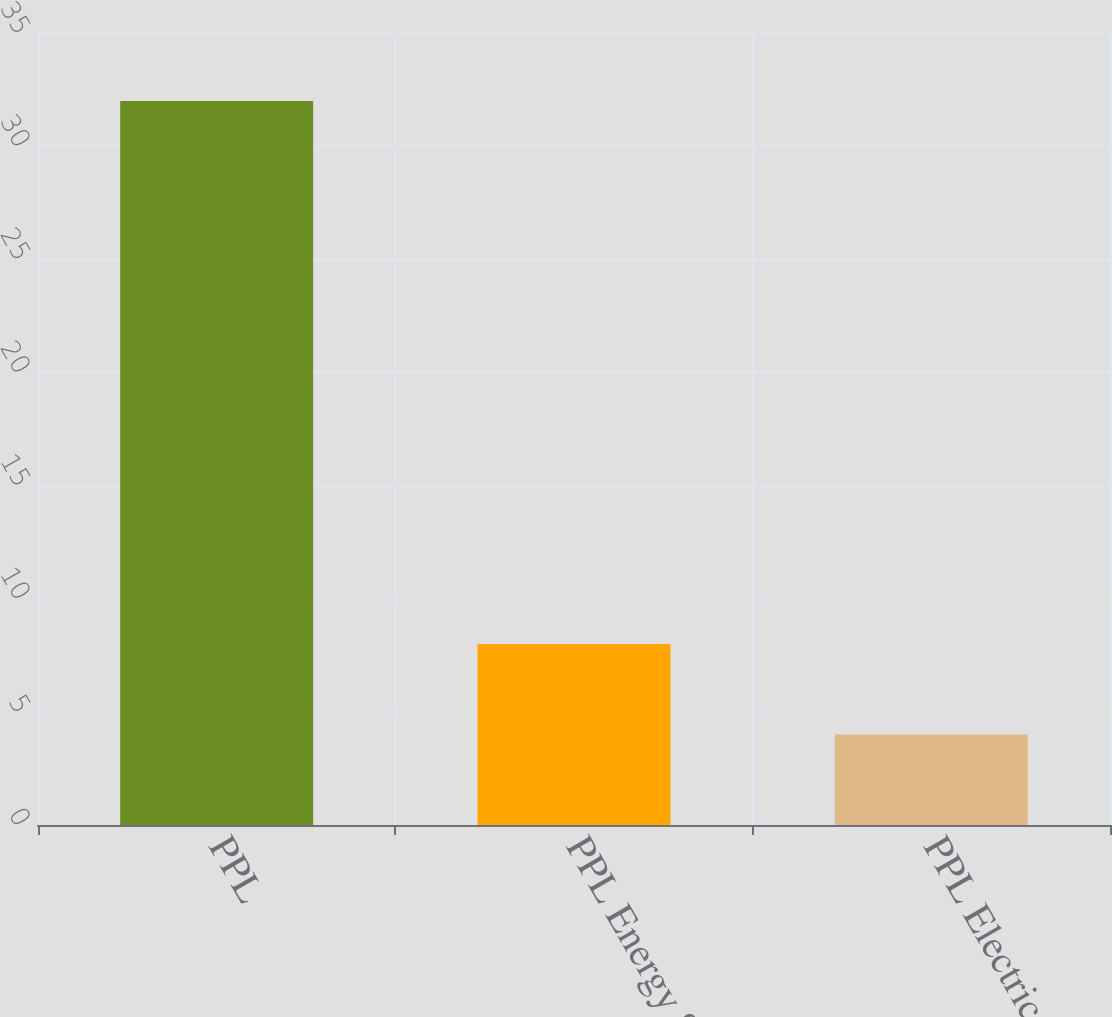Convert chart to OTSL. <chart><loc_0><loc_0><loc_500><loc_500><bar_chart><fcel>PPL<fcel>PPL Energy Supply<fcel>PPL Electric<nl><fcel>32<fcel>8<fcel>4<nl></chart> 